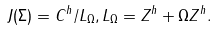<formula> <loc_0><loc_0><loc_500><loc_500>J ( \Sigma ) = C ^ { h } / L _ { \Omega } , L _ { \Omega } = Z ^ { h } + \Omega Z ^ { h } .</formula> 